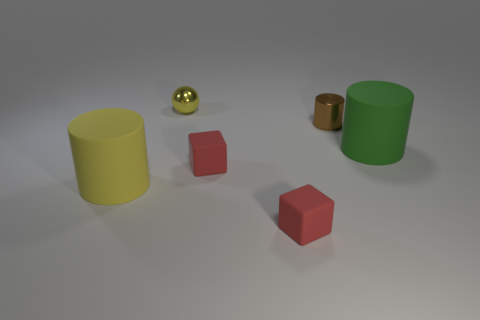There is a yellow thing to the left of the yellow thing behind the large yellow matte cylinder; what size is it?
Offer a terse response. Large. What number of other things are the same color as the small cylinder?
Provide a short and direct response. 0. What is the yellow cylinder made of?
Offer a terse response. Rubber. Are any small yellow spheres visible?
Offer a very short reply. Yes. Is the number of small brown things on the right side of the green cylinder the same as the number of yellow matte cylinders?
Your response must be concise. No. Is there any other thing that is the same material as the large green object?
Give a very brief answer. Yes. How many large objects are either cyan rubber cylinders or cylinders?
Your answer should be compact. 2. There is a big matte object that is the same color as the small metal ball; what shape is it?
Provide a short and direct response. Cylinder. Does the small red thing that is in front of the big yellow rubber cylinder have the same material as the brown cylinder?
Offer a very short reply. No. There is a large cylinder that is on the left side of the cylinder on the right side of the brown shiny cylinder; what is its material?
Give a very brief answer. Rubber. 